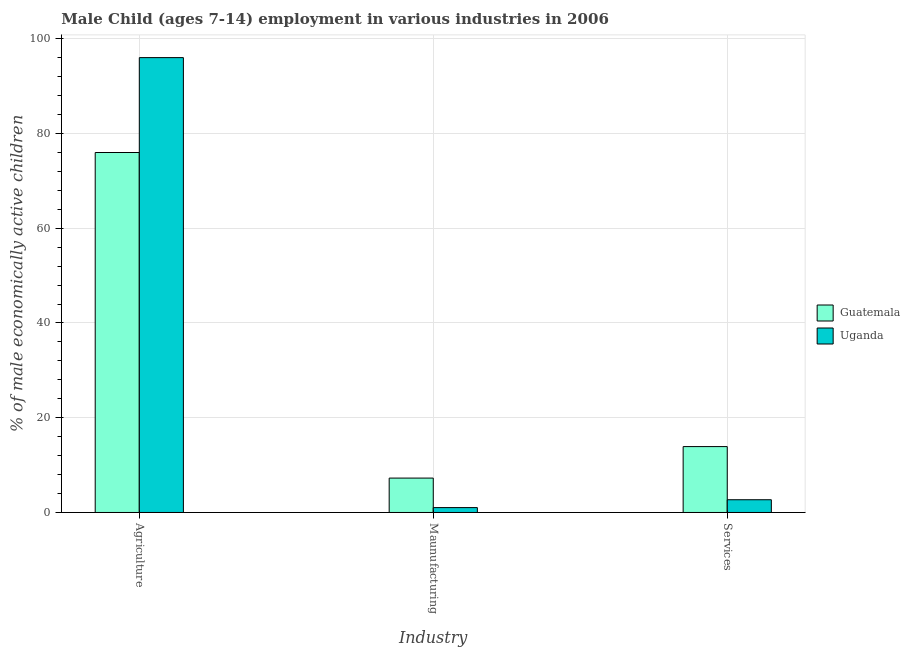How many bars are there on the 3rd tick from the left?
Ensure brevity in your answer.  2. How many bars are there on the 3rd tick from the right?
Give a very brief answer. 2. What is the label of the 2nd group of bars from the left?
Offer a terse response. Maunufacturing. What is the percentage of economically active children in agriculture in Uganda?
Provide a succinct answer. 96.02. Across all countries, what is the maximum percentage of economically active children in agriculture?
Ensure brevity in your answer.  96.02. Across all countries, what is the minimum percentage of economically active children in agriculture?
Keep it short and to the point. 75.99. In which country was the percentage of economically active children in services maximum?
Provide a succinct answer. Guatemala. In which country was the percentage of economically active children in services minimum?
Give a very brief answer. Uganda. What is the total percentage of economically active children in agriculture in the graph?
Keep it short and to the point. 172.01. What is the difference between the percentage of economically active children in manufacturing in Uganda and that in Guatemala?
Your response must be concise. -6.23. What is the difference between the percentage of economically active children in manufacturing in Guatemala and the percentage of economically active children in services in Uganda?
Provide a succinct answer. 4.57. What is the average percentage of economically active children in agriculture per country?
Your answer should be very brief. 86. What is the difference between the percentage of economically active children in services and percentage of economically active children in manufacturing in Guatemala?
Ensure brevity in your answer.  6.65. In how many countries, is the percentage of economically active children in services greater than 40 %?
Your answer should be compact. 0. What is the ratio of the percentage of economically active children in services in Guatemala to that in Uganda?
Make the answer very short. 5.17. Is the percentage of economically active children in services in Uganda less than that in Guatemala?
Your answer should be compact. Yes. Is the difference between the percentage of economically active children in services in Guatemala and Uganda greater than the difference between the percentage of economically active children in manufacturing in Guatemala and Uganda?
Your answer should be compact. Yes. What is the difference between the highest and the second highest percentage of economically active children in services?
Offer a very short reply. 11.22. What is the difference between the highest and the lowest percentage of economically active children in manufacturing?
Offer a terse response. 6.23. In how many countries, is the percentage of economically active children in agriculture greater than the average percentage of economically active children in agriculture taken over all countries?
Provide a succinct answer. 1. Is the sum of the percentage of economically active children in agriculture in Guatemala and Uganda greater than the maximum percentage of economically active children in services across all countries?
Ensure brevity in your answer.  Yes. What does the 2nd bar from the left in Agriculture represents?
Offer a very short reply. Uganda. What does the 2nd bar from the right in Maunufacturing represents?
Give a very brief answer. Guatemala. How many bars are there?
Ensure brevity in your answer.  6. Are the values on the major ticks of Y-axis written in scientific E-notation?
Your answer should be compact. No. Where does the legend appear in the graph?
Offer a very short reply. Center right. What is the title of the graph?
Provide a short and direct response. Male Child (ages 7-14) employment in various industries in 2006. Does "Venezuela" appear as one of the legend labels in the graph?
Offer a very short reply. No. What is the label or title of the X-axis?
Keep it short and to the point. Industry. What is the label or title of the Y-axis?
Keep it short and to the point. % of male economically active children. What is the % of male economically active children of Guatemala in Agriculture?
Provide a short and direct response. 75.99. What is the % of male economically active children in Uganda in Agriculture?
Offer a terse response. 96.02. What is the % of male economically active children in Guatemala in Maunufacturing?
Provide a succinct answer. 7.26. What is the % of male economically active children of Guatemala in Services?
Offer a terse response. 13.91. What is the % of male economically active children of Uganda in Services?
Your answer should be compact. 2.69. Across all Industry, what is the maximum % of male economically active children in Guatemala?
Your answer should be compact. 75.99. Across all Industry, what is the maximum % of male economically active children of Uganda?
Offer a very short reply. 96.02. Across all Industry, what is the minimum % of male economically active children of Guatemala?
Offer a very short reply. 7.26. Across all Industry, what is the minimum % of male economically active children of Uganda?
Your answer should be very brief. 1.03. What is the total % of male economically active children in Guatemala in the graph?
Ensure brevity in your answer.  97.16. What is the total % of male economically active children in Uganda in the graph?
Your response must be concise. 99.74. What is the difference between the % of male economically active children in Guatemala in Agriculture and that in Maunufacturing?
Make the answer very short. 68.73. What is the difference between the % of male economically active children of Uganda in Agriculture and that in Maunufacturing?
Your response must be concise. 94.99. What is the difference between the % of male economically active children of Guatemala in Agriculture and that in Services?
Offer a very short reply. 62.08. What is the difference between the % of male economically active children of Uganda in Agriculture and that in Services?
Make the answer very short. 93.33. What is the difference between the % of male economically active children of Guatemala in Maunufacturing and that in Services?
Provide a succinct answer. -6.65. What is the difference between the % of male economically active children in Uganda in Maunufacturing and that in Services?
Your response must be concise. -1.66. What is the difference between the % of male economically active children of Guatemala in Agriculture and the % of male economically active children of Uganda in Maunufacturing?
Make the answer very short. 74.96. What is the difference between the % of male economically active children of Guatemala in Agriculture and the % of male economically active children of Uganda in Services?
Ensure brevity in your answer.  73.3. What is the difference between the % of male economically active children of Guatemala in Maunufacturing and the % of male economically active children of Uganda in Services?
Offer a very short reply. 4.57. What is the average % of male economically active children in Guatemala per Industry?
Your response must be concise. 32.39. What is the average % of male economically active children of Uganda per Industry?
Your answer should be compact. 33.25. What is the difference between the % of male economically active children of Guatemala and % of male economically active children of Uganda in Agriculture?
Provide a short and direct response. -20.03. What is the difference between the % of male economically active children in Guatemala and % of male economically active children in Uganda in Maunufacturing?
Your response must be concise. 6.23. What is the difference between the % of male economically active children in Guatemala and % of male economically active children in Uganda in Services?
Ensure brevity in your answer.  11.22. What is the ratio of the % of male economically active children in Guatemala in Agriculture to that in Maunufacturing?
Provide a short and direct response. 10.47. What is the ratio of the % of male economically active children in Uganda in Agriculture to that in Maunufacturing?
Your answer should be compact. 93.22. What is the ratio of the % of male economically active children of Guatemala in Agriculture to that in Services?
Provide a short and direct response. 5.46. What is the ratio of the % of male economically active children in Uganda in Agriculture to that in Services?
Provide a short and direct response. 35.7. What is the ratio of the % of male economically active children in Guatemala in Maunufacturing to that in Services?
Ensure brevity in your answer.  0.52. What is the ratio of the % of male economically active children in Uganda in Maunufacturing to that in Services?
Ensure brevity in your answer.  0.38. What is the difference between the highest and the second highest % of male economically active children of Guatemala?
Keep it short and to the point. 62.08. What is the difference between the highest and the second highest % of male economically active children in Uganda?
Make the answer very short. 93.33. What is the difference between the highest and the lowest % of male economically active children in Guatemala?
Offer a terse response. 68.73. What is the difference between the highest and the lowest % of male economically active children of Uganda?
Provide a succinct answer. 94.99. 